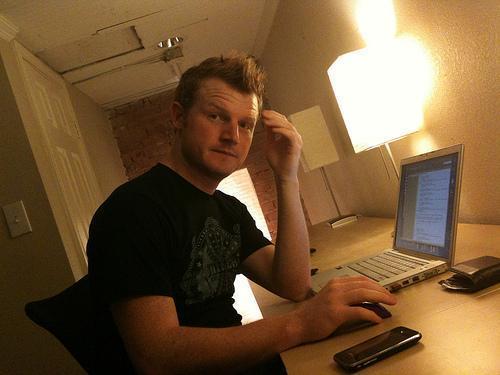How many people are in this photo?
Give a very brief answer. 1. How many hands are visible?
Give a very brief answer. 2. 